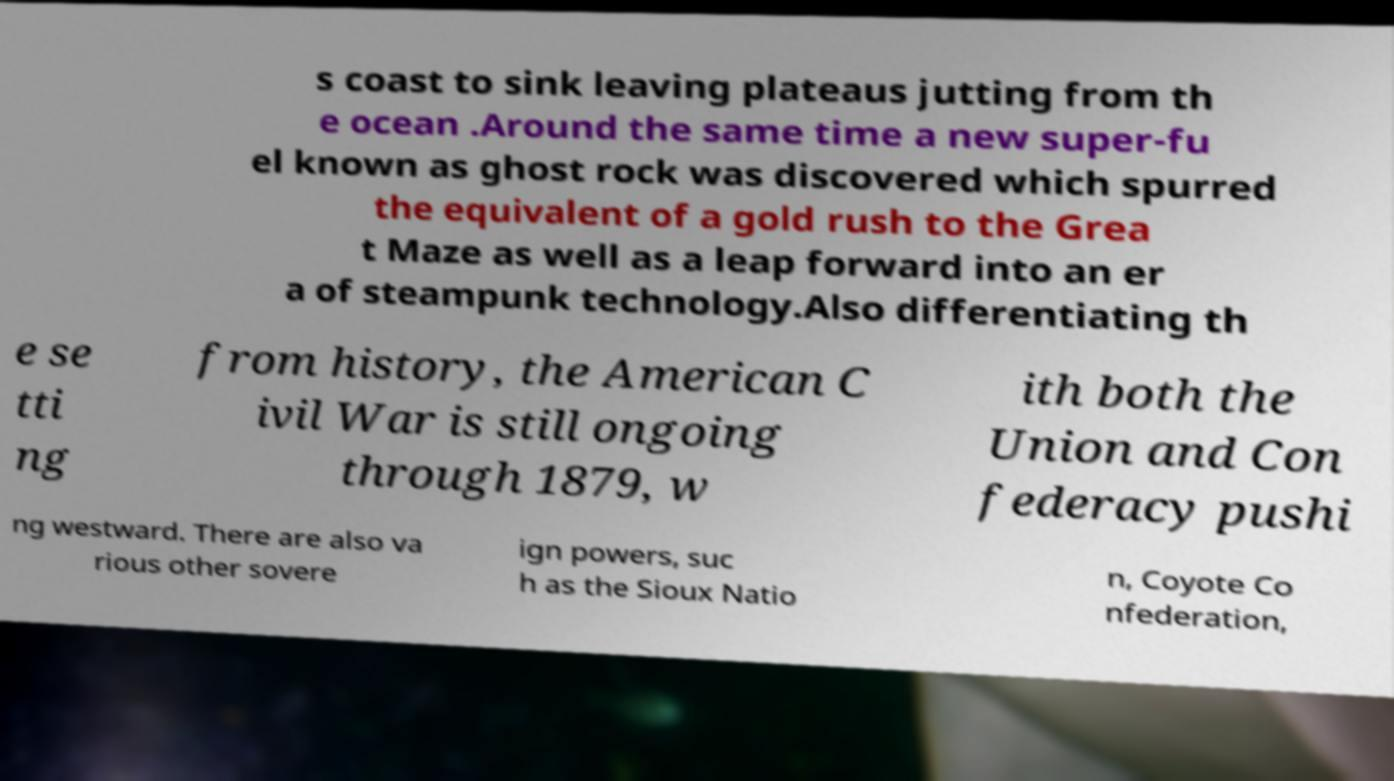Could you assist in decoding the text presented in this image and type it out clearly? s coast to sink leaving plateaus jutting from th e ocean .Around the same time a new super-fu el known as ghost rock was discovered which spurred the equivalent of a gold rush to the Grea t Maze as well as a leap forward into an er a of steampunk technology.Also differentiating th e se tti ng from history, the American C ivil War is still ongoing through 1879, w ith both the Union and Con federacy pushi ng westward. There are also va rious other sovere ign powers, suc h as the Sioux Natio n, Coyote Co nfederation, 